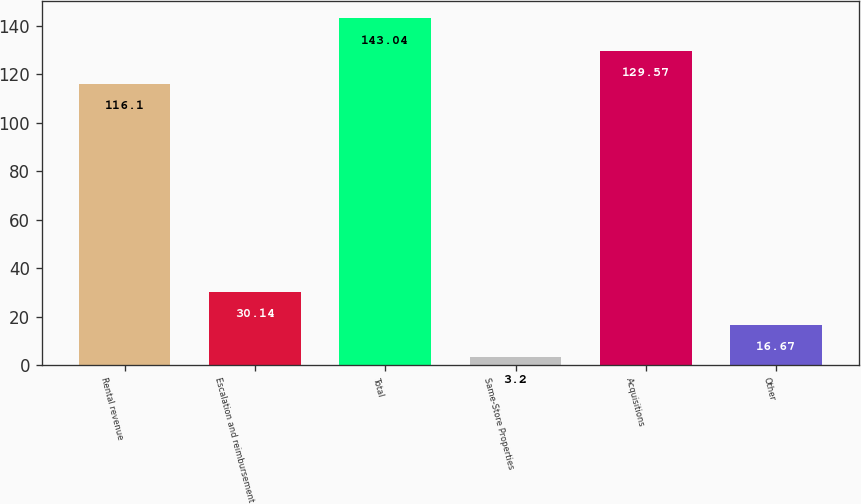Convert chart. <chart><loc_0><loc_0><loc_500><loc_500><bar_chart><fcel>Rental revenue<fcel>Escalation and reimbursement<fcel>Total<fcel>Same-Store Properties<fcel>Acquisitions<fcel>Other<nl><fcel>116.1<fcel>30.14<fcel>143.04<fcel>3.2<fcel>129.57<fcel>16.67<nl></chart> 